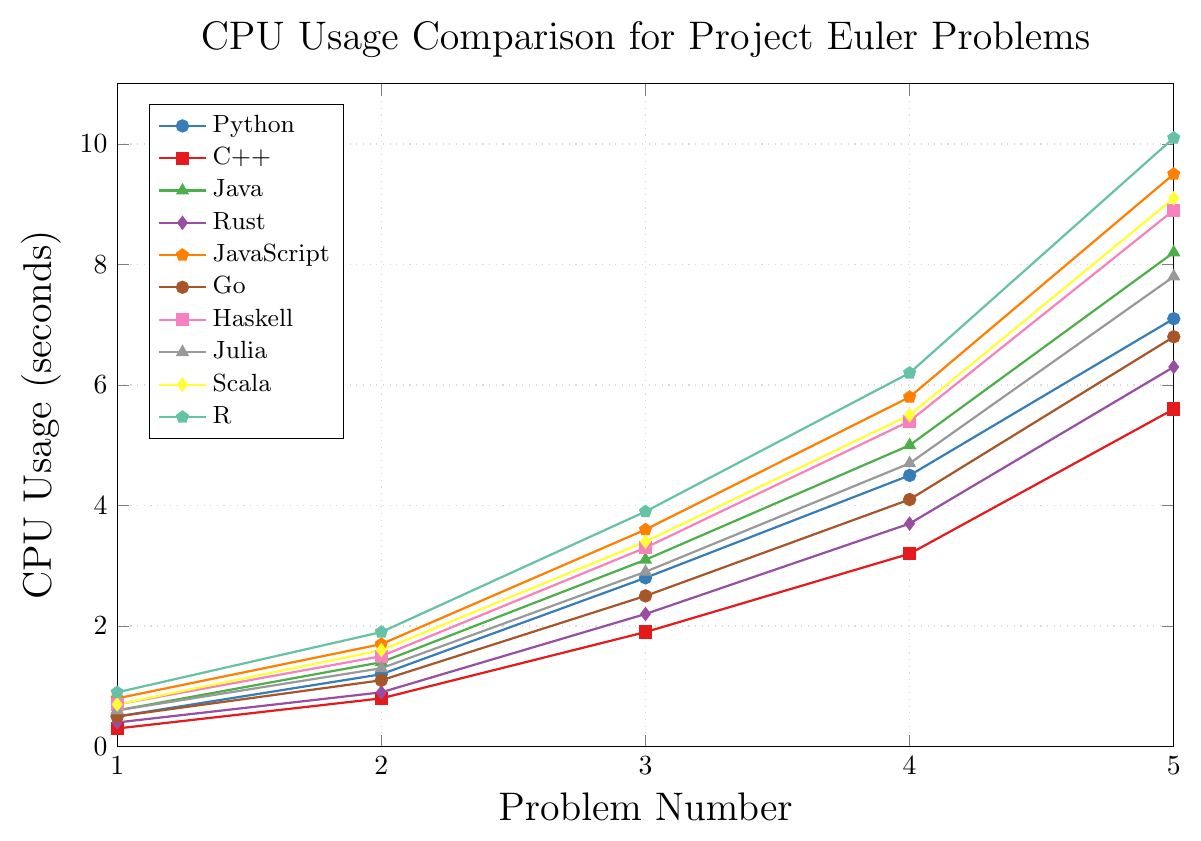Which programming language had the highest CPU usage for Problem 5? From the figure, identify the programming language with the point farthest up on the y-axis for Problem 5 (x=5). This point is for R.
Answer: R How does the CPU usage of JavaScript for Problem 3 compare to that of Rust for the same problem? Locate the points for JavaScript and Rust at the x-coordinate of 3. JavaScript has a CPU usage of 3.6 seconds and Rust has 2.2 seconds. JavaScript uses more CPU for Problem 3.
Answer: JavaScript uses more CPU What is the average CPU usage for Python across all problems? First, sum up the CPU usage values for Python (0.5+1.2+2.8+4.5+7.1=16.1). Then, divide this sum by the number of problems (5). The average is 16.1/5 = 3.22 seconds.
Answer: 3.22 seconds Which language had the smallest increase in CPU usage between Problem 1 and Problem 2? Calculate the differences between Problem 1 and Problem 2 for all languages. Python: 0.7, C++: 0.5, Java: 0.8, Rust: 0.5, JavaScript: 0.9, Go: 0.6, Haskell: 0.8, Julia: 0.7, Scala: 0.9, R: 1. The smallest is 0.5, shared by C++ and Rust.
Answer: C++ and Rust Between Problem 1 and Problem 5, which programming language had the steepest increase in CPU usage? Compare the total increase in CPU usage from Problem 1 to Problem 5 for each language. Python: 6.6, C++: 5.3, Java: 7.6, Rust: 5.9, JavaScript: 8.7, Go: 6.3, Haskell: 8.2, Julia: 7.2, Scala: 8.4, R: 9.2. R has the steepest increase.
Answer: R Which language shows nearly linear growth in CPU usage across all problems? Identify the language whose plot approximates a straight line with a uniform slope. C++, Rust, and Go appear to have nearly linear growth.
Answer: C++, Rust, and Go Among the visual attributes, which language is represented by a red line? Locate the color-coded legend that labels each line’s color. The red line is associated with C++.
Answer: C++ What is the midpoint of CPU usage for JavaScript for Problems 2 and 4? Add the values of JavaScript for Problems 2 and 4 (1.7+5.8=7.5), then divide by 2 to find the midpoint. 7.5/2 = 3.75 seconds.
Answer: 3.75 seconds Which languages have a CPU usage of less than 1 second for Problem 2? From the figure, identify the languages with CPU usage at less than 1 second on the y-axis for Problem 2 (x=2). C++ and Rust have usage under 1 second.
Answer: C++ and Rust 